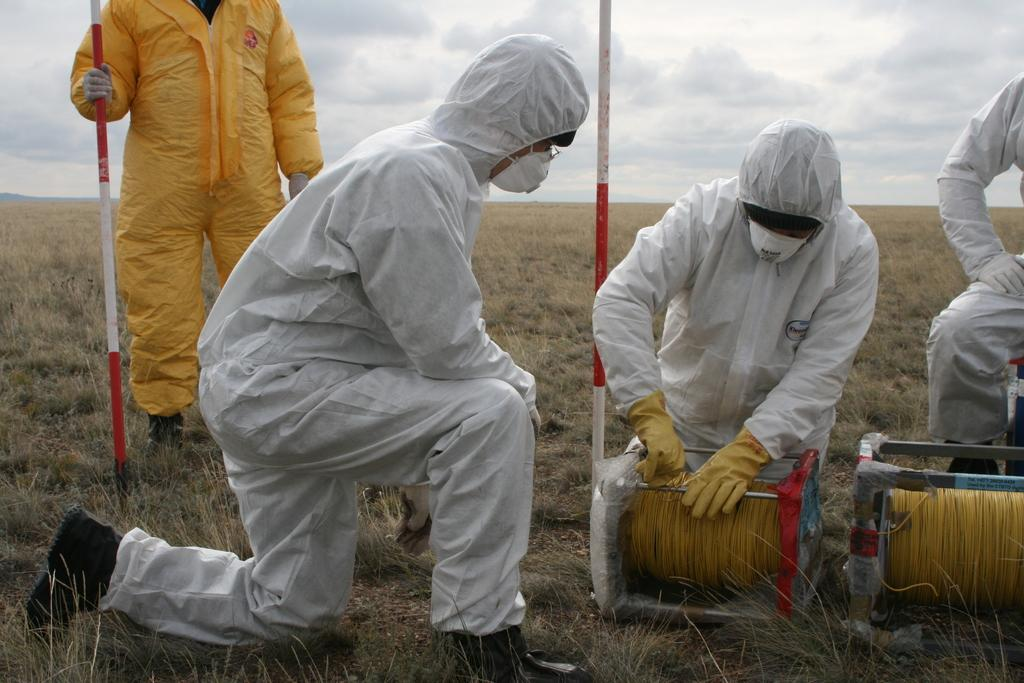What is the person on the left side of the image holding? The person is holding a stick. What objects can be seen in the image related to wire? Wire rollers are visible in the image. How many people are in the image? There are people in the image. What is the condition of the sky in the image? Clouds are present in the sky. What type of vegetation is visible in the image? Grass is visible in the image. What type of shoes is the person wearing in the image? The image does not show the person's shoes, so it cannot be determined from the image. 